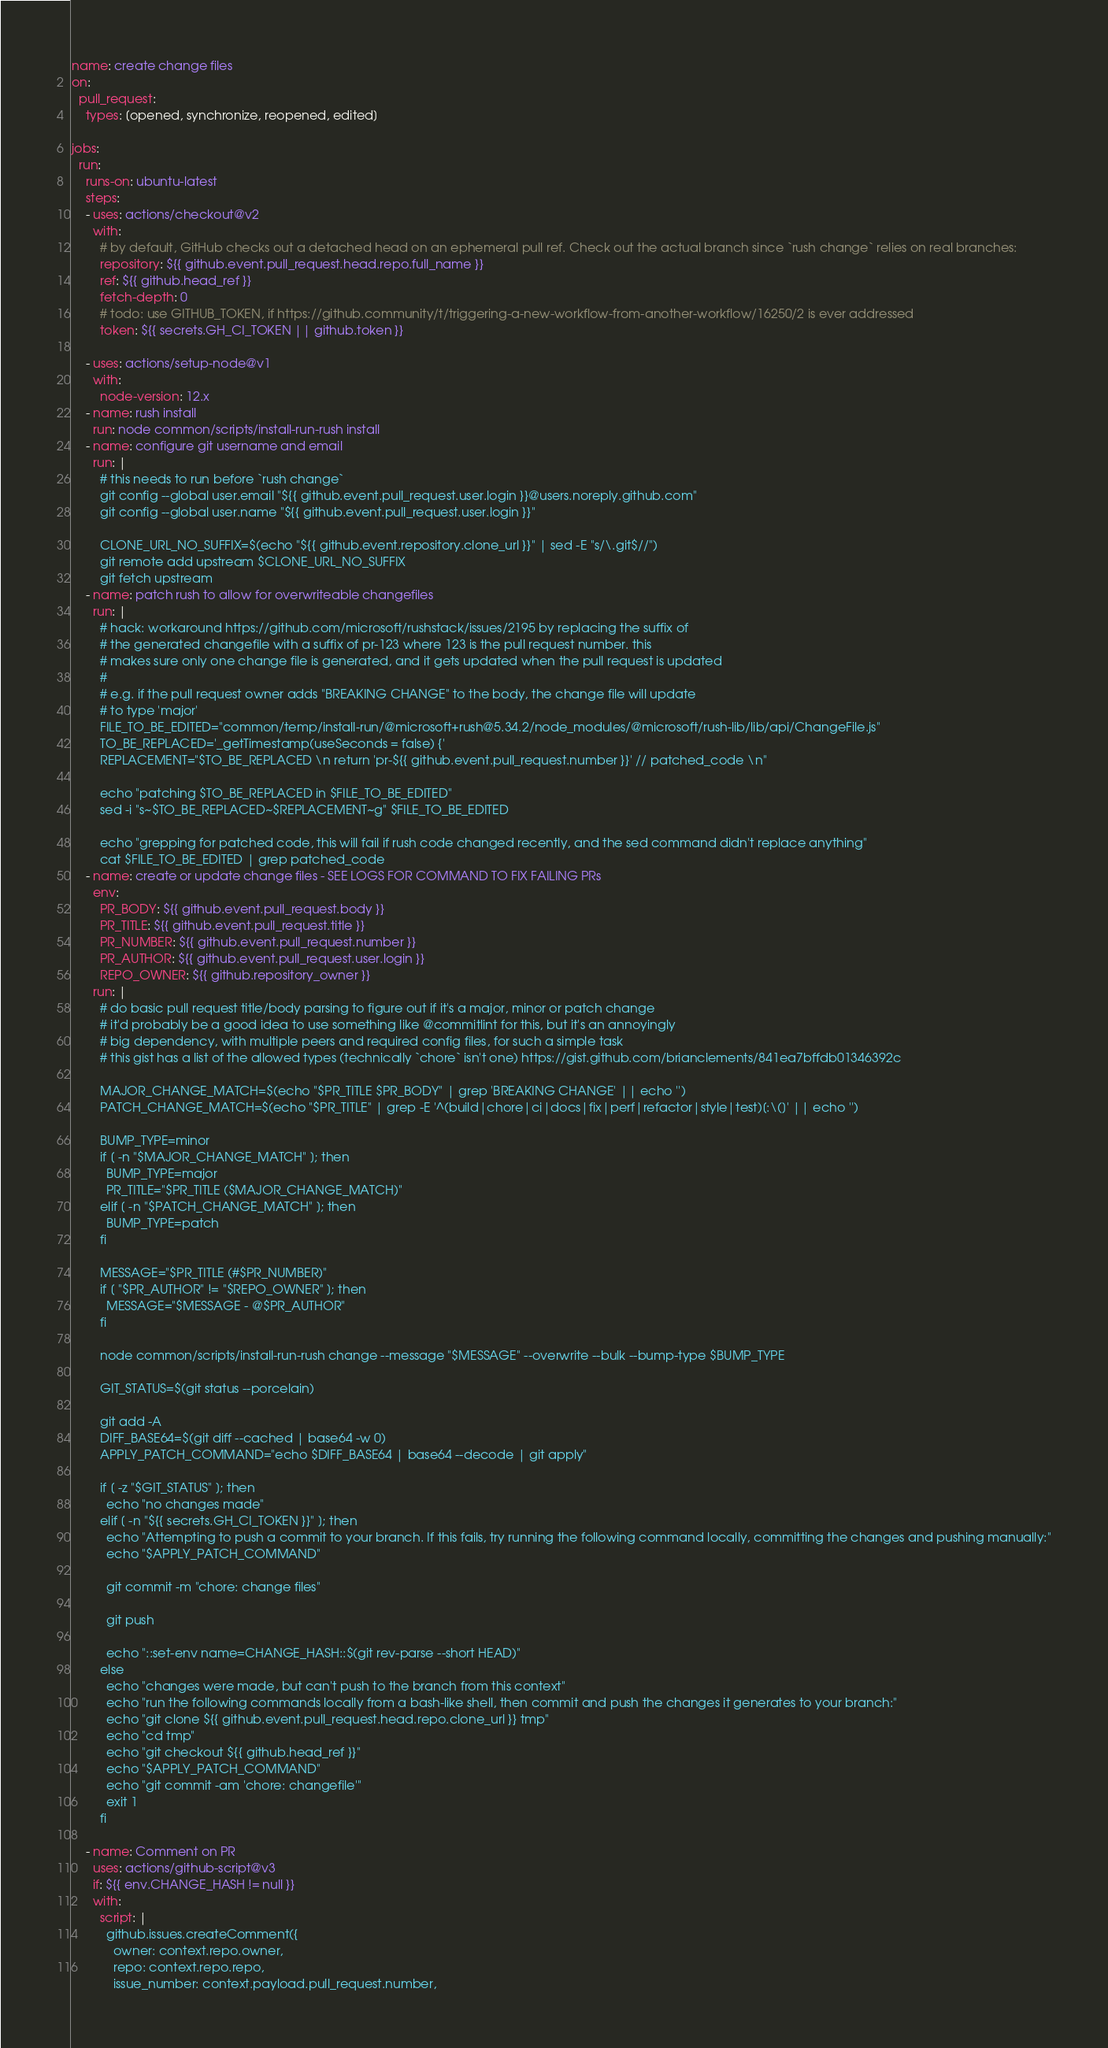<code> <loc_0><loc_0><loc_500><loc_500><_YAML_>name: create change files
on:
  pull_request:
    types: [opened, synchronize, reopened, edited]

jobs:
  run:
    runs-on: ubuntu-latest
    steps:
    - uses: actions/checkout@v2
      with:
        # by default, GitHub checks out a detached head on an ephemeral pull ref. Check out the actual branch since `rush change` relies on real branches:
        repository: ${{ github.event.pull_request.head.repo.full_name }}
        ref: ${{ github.head_ref }}
        fetch-depth: 0
        # todo: use GITHUB_TOKEN, if https://github.community/t/triggering-a-new-workflow-from-another-workflow/16250/2 is ever addressed
        token: ${{ secrets.GH_CI_TOKEN || github.token }}

    - uses: actions/setup-node@v1
      with:
        node-version: 12.x
    - name: rush install
      run: node common/scripts/install-run-rush install
    - name: configure git username and email
      run: |
        # this needs to run before `rush change`
        git config --global user.email "${{ github.event.pull_request.user.login }}@users.noreply.github.com"
        git config --global user.name "${{ github.event.pull_request.user.login }}"
        
        CLONE_URL_NO_SUFFIX=$(echo "${{ github.event.repository.clone_url }}" | sed -E "s/\.git$//")
        git remote add upstream $CLONE_URL_NO_SUFFIX
        git fetch upstream
    - name: patch rush to allow for overwriteable changefiles
      run: |
        # hack: workaround https://github.com/microsoft/rushstack/issues/2195 by replacing the suffix of
        # the generated changefile with a suffix of pr-123 where 123 is the pull request number. this
        # makes sure only one change file is generated, and it gets updated when the pull request is updated
        #
        # e.g. if the pull request owner adds "BREAKING CHANGE" to the body, the change file will update
        # to type 'major'
        FILE_TO_BE_EDITED="common/temp/install-run/@microsoft+rush@5.34.2/node_modules/@microsoft/rush-lib/lib/api/ChangeFile.js"
        TO_BE_REPLACED='_getTimestamp(useSeconds = false) {'
        REPLACEMENT="$TO_BE_REPLACED \n return 'pr-${{ github.event.pull_request.number }}' // patched_code \n"

        echo "patching $TO_BE_REPLACED in $FILE_TO_BE_EDITED"
        sed -i "s~$TO_BE_REPLACED~$REPLACEMENT~g" $FILE_TO_BE_EDITED

        echo "grepping for patched code, this will fail if rush code changed recently, and the sed command didn't replace anything"
        cat $FILE_TO_BE_EDITED | grep patched_code
    - name: create or update change files - SEE LOGS FOR COMMAND TO FIX FAILING PRs
      env:
        PR_BODY: ${{ github.event.pull_request.body }}
        PR_TITLE: ${{ github.event.pull_request.title }}
        PR_NUMBER: ${{ github.event.pull_request.number }}
        PR_AUTHOR: ${{ github.event.pull_request.user.login }}
        REPO_OWNER: ${{ github.repository_owner }}
      run: |
        # do basic pull request title/body parsing to figure out if it's a major, minor or patch change
        # it'd probably be a good idea to use something like @commitlint for this, but it's an annoyingly
        # big dependency, with multiple peers and required config files, for such a simple task
        # this gist has a list of the allowed types (technically `chore` isn't one) https://gist.github.com/brianclements/841ea7bffdb01346392c

        MAJOR_CHANGE_MATCH=$(echo "$PR_TITLE $PR_BODY" | grep 'BREAKING CHANGE' || echo '')
        PATCH_CHANGE_MATCH=$(echo "$PR_TITLE" | grep -E '^(build|chore|ci|docs|fix|perf|refactor|style|test)[:\(]' || echo '')
        
        BUMP_TYPE=minor
        if [ -n "$MAJOR_CHANGE_MATCH" ]; then
          BUMP_TYPE=major
          PR_TITLE="$PR_TITLE ($MAJOR_CHANGE_MATCH)"
        elif [ -n "$PATCH_CHANGE_MATCH" ]; then
          BUMP_TYPE=patch
        fi

        MESSAGE="$PR_TITLE (#$PR_NUMBER)"
        if [ "$PR_AUTHOR" != "$REPO_OWNER" ]; then
          MESSAGE="$MESSAGE - @$PR_AUTHOR"
        fi

        node common/scripts/install-run-rush change --message "$MESSAGE" --overwrite --bulk --bump-type $BUMP_TYPE

        GIT_STATUS=$(git status --porcelain)

        git add -A
        DIFF_BASE64=$(git diff --cached | base64 -w 0)
        APPLY_PATCH_COMMAND="echo $DIFF_BASE64 | base64 --decode | git apply"

        if [ -z "$GIT_STATUS" ]; then
          echo "no changes made"
        elif [ -n "${{ secrets.GH_CI_TOKEN }}" ]; then
          echo "Attempting to push a commit to your branch. If this fails, try running the following command locally, committing the changes and pushing manually:"
          echo "$APPLY_PATCH_COMMAND"

          git commit -m "chore: change files"

          git push

          echo "::set-env name=CHANGE_HASH::$(git rev-parse --short HEAD)"
        else
          echo "changes were made, but can't push to the branch from this context"
          echo "run the following commands locally from a bash-like shell, then commit and push the changes it generates to your branch:"
          echo "git clone ${{ github.event.pull_request.head.repo.clone_url }} tmp"
          echo "cd tmp"
          echo "git checkout ${{ github.head_ref }}"
          echo "$APPLY_PATCH_COMMAND"
          echo "git commit -am 'chore: changefile'"
          exit 1
        fi

    - name: Comment on PR
      uses: actions/github-script@v3
      if: ${{ env.CHANGE_HASH != null }}
      with:
        script: |
          github.issues.createComment({
            owner: context.repo.owner,
            repo: context.repo.repo,
            issue_number: context.payload.pull_request.number,</code> 